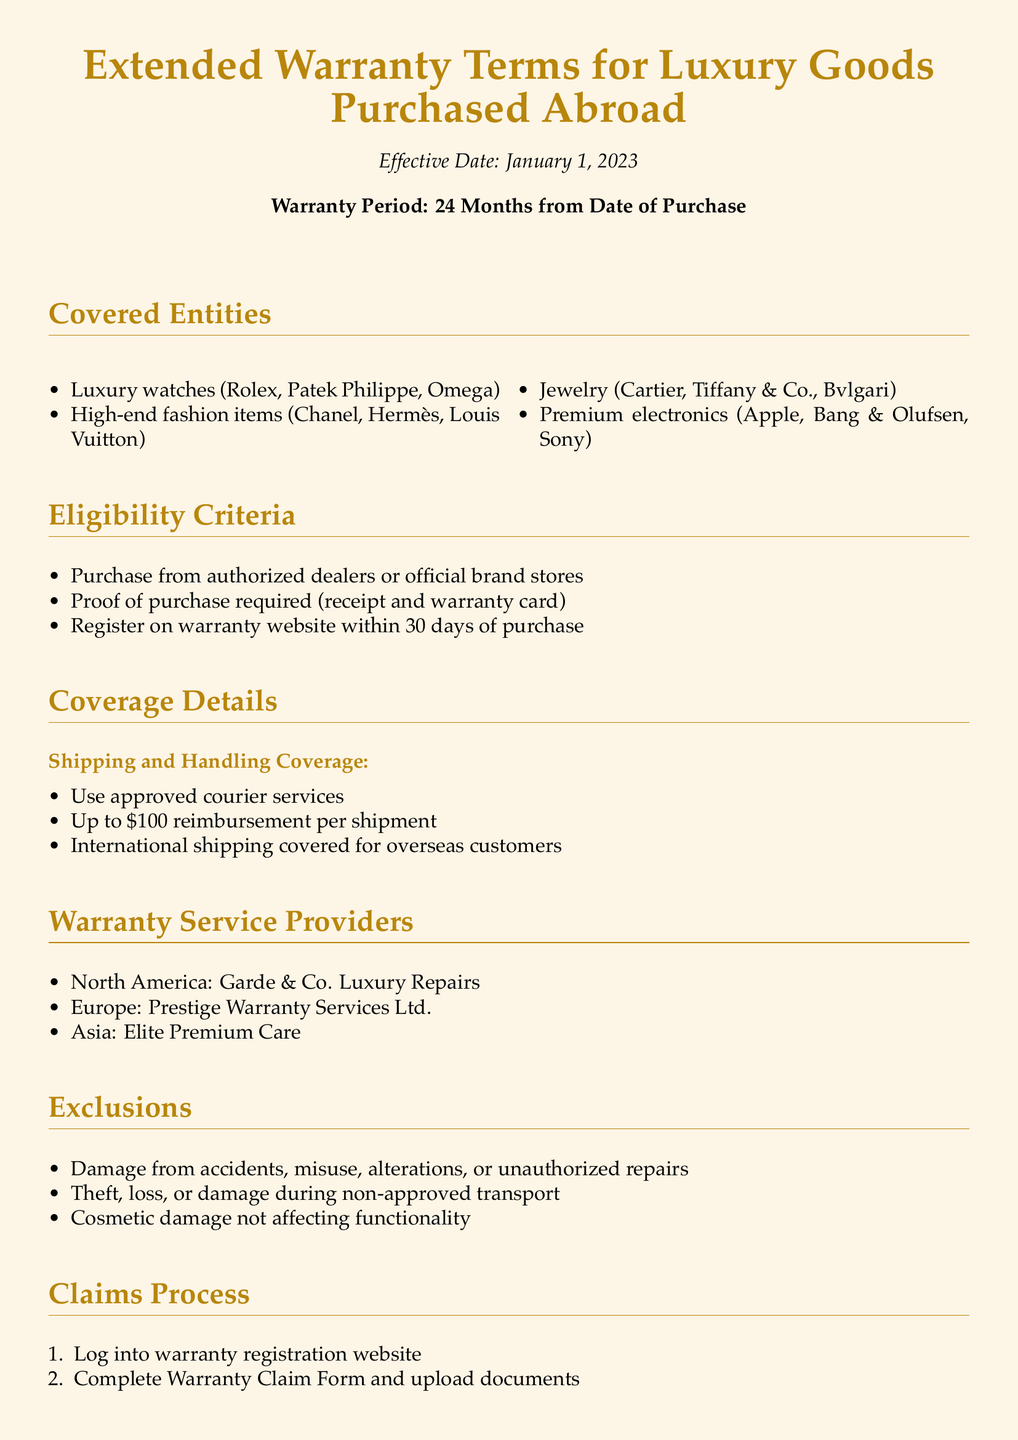What is the effective date of the warranty? The effective date of the warranty is specified at the beginning of the document, which is January 1, 2023.
Answer: January 1, 2023 What is the warranty period? The warranty period is stated in the document as 24 months from the date of purchase.
Answer: 24 Months Which luxury item brands are covered? The document lists specific luxury item brands, including Rolex, Chanel, and Cartier among others.
Answer: Rolex, Chanel, Cartier What is the reimbursement limit for shipping? The document mentions a specific reimbursement limit for shipping expenses.
Answer: $100 Where should claims be submitted? The claims submission process involves logging into a specific website mentioned in the document.
Answer: Warranty registration website What type of damage is excluded from the warranty? The document lists specific types of damage that are not covered, such as damage from accidents or misuse.
Answer: Damage from accidents What must be done within 30 days of purchase for warranty eligibility? The document indicates that registration on a specific website must be completed within this time frame.
Answer: Register on warranty website How long does the claims approval process take? The approval timeline is provided in the claims process section, indicating how long it typically takes.
Answer: 5-7 business days Which company provides warranty services in Asia? The document lists specific service providers by region, including the one for Asia.
Answer: Elite Premium Care 